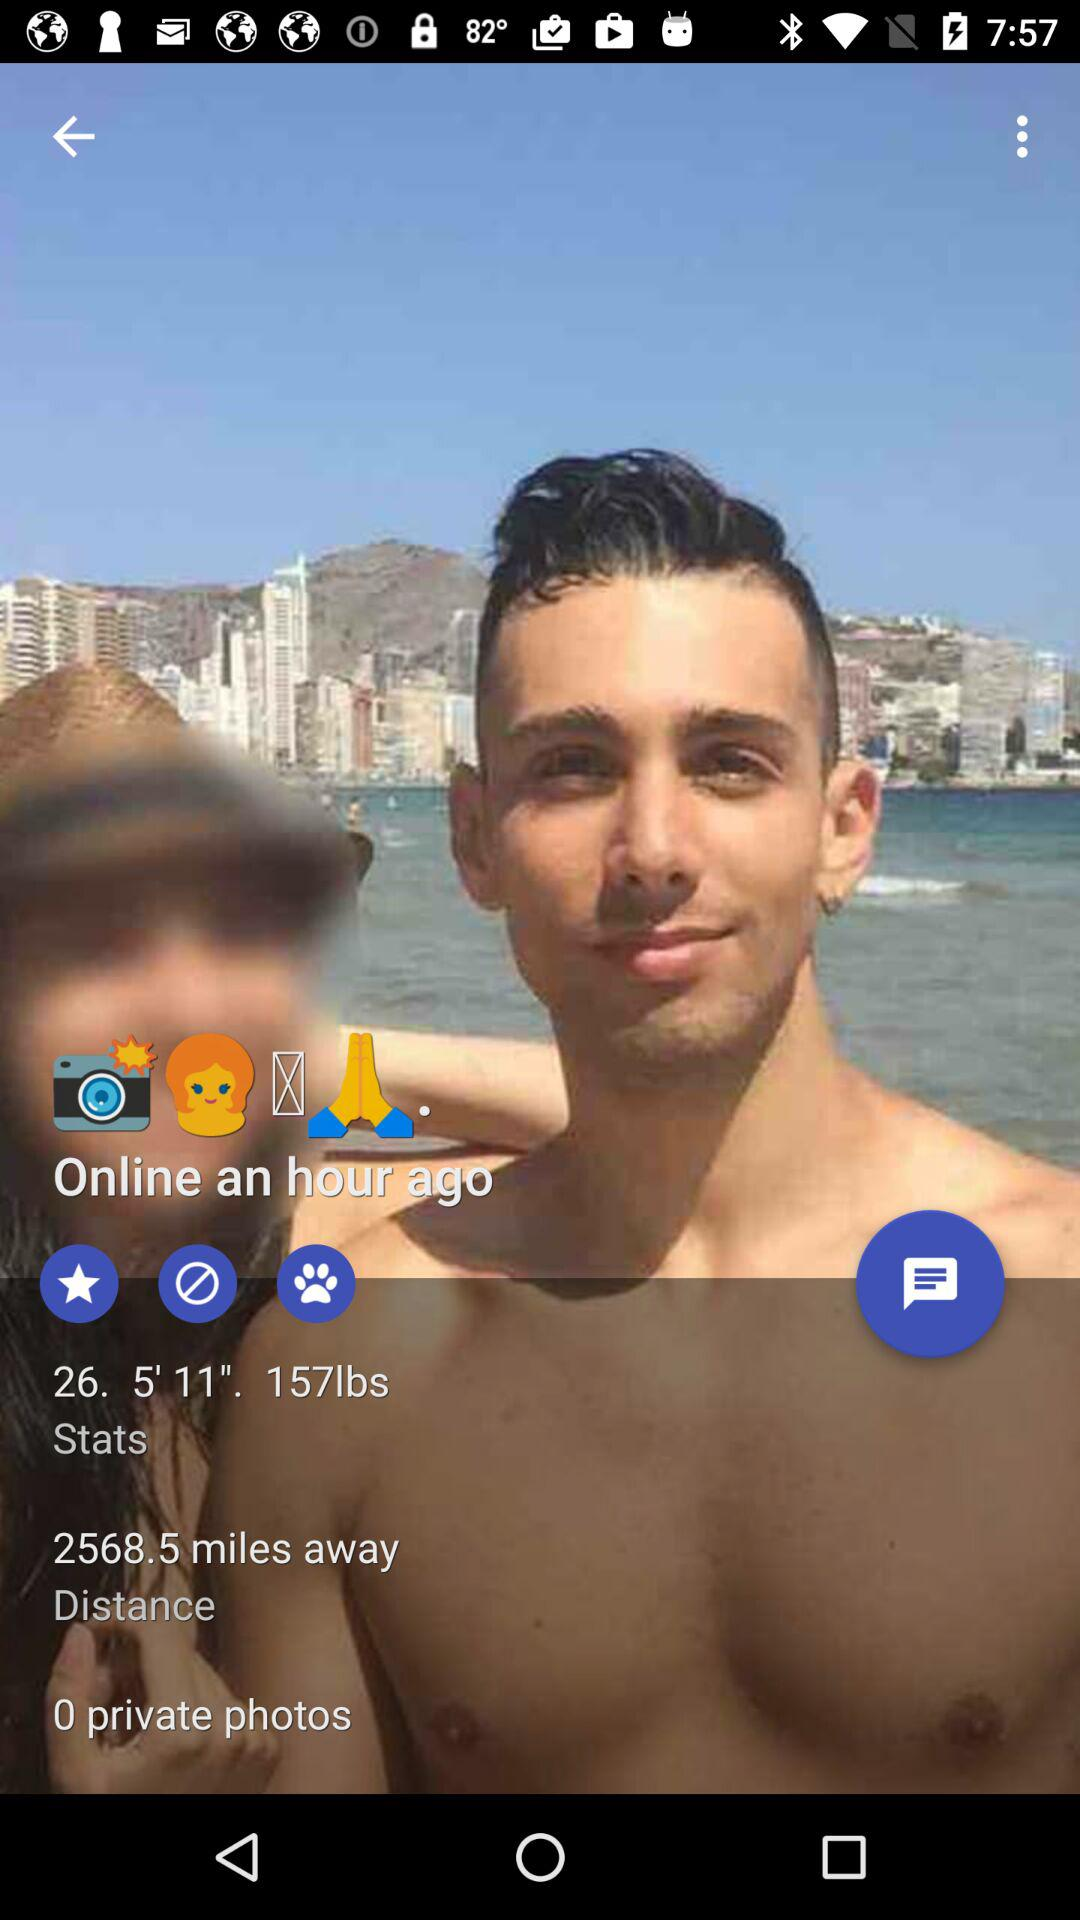What is the distance? The distance is 2568.5 miles. 